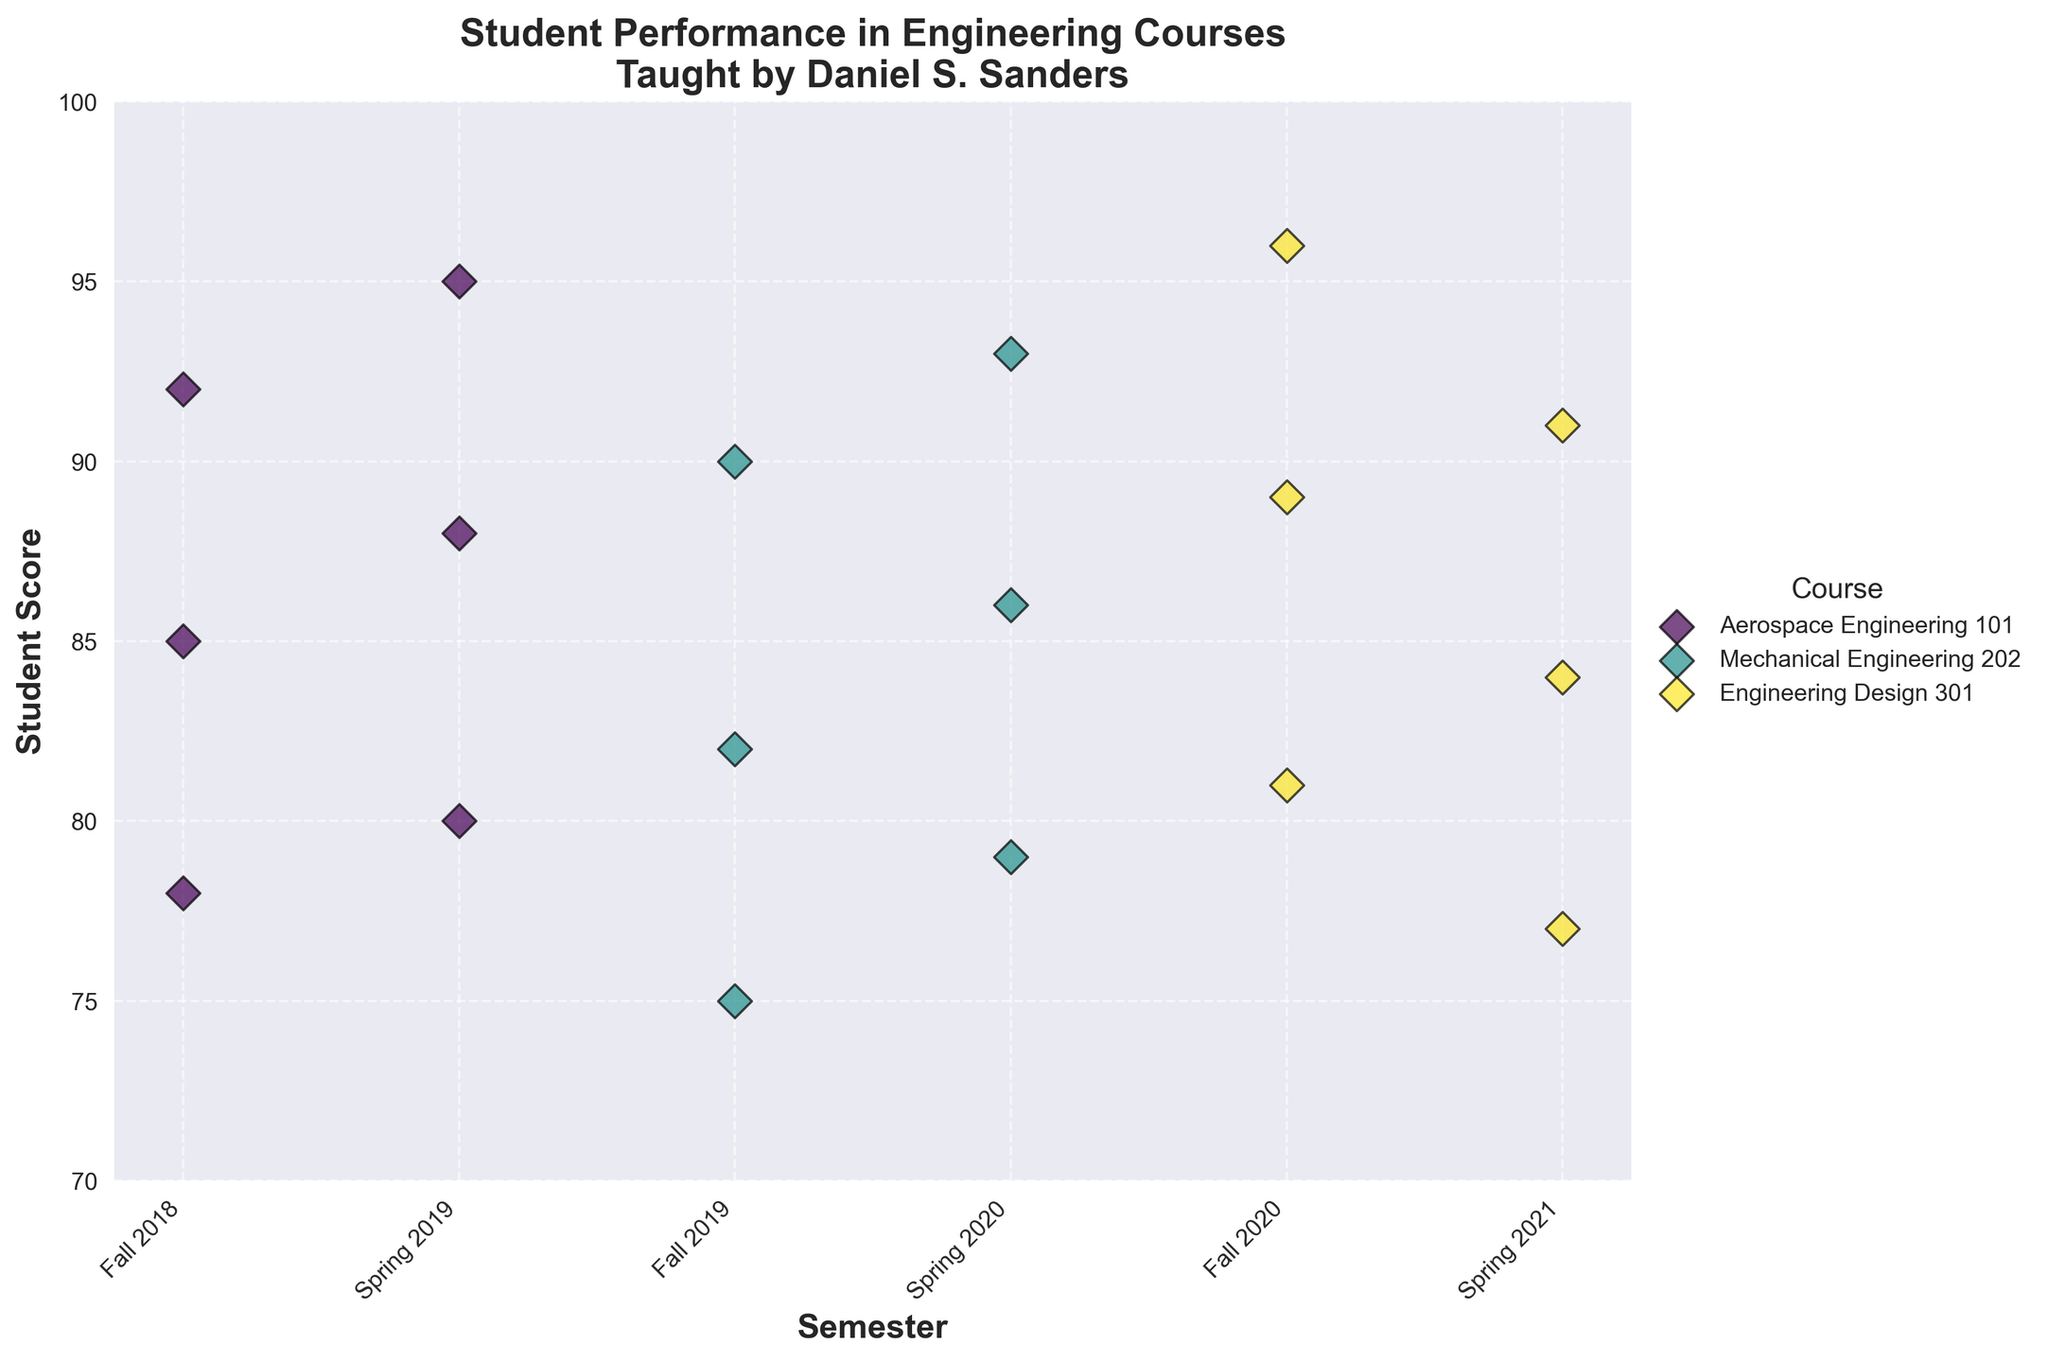What is the title of the figure? The title is usually at the top of the figure. In this case, it reads "Student Performance in Engineering Courses\nTaught by Daniel S. Sanders".
Answer: Student Performance in Engineering Courses Taught by Daniel S. Sanders What are the labels on the x-axis and y-axis? The labels are typically located at the axes. The x-axis label is 'Semester' and the y-axis label is 'Student Score'.
Answer: Semester and Student Score Which semester had the highest number of unique engineering courses? By observing the x-axis categories, note which semester labels have the highest distinct courses plotted. Both Fall 2018 and Spring 2019 show data for just Aerospace Engineering 101, Fall 2019 and Spring 2020 for Mechanical Engineering 202, and Fall 2020 and Spring 2021 for Engineering Design 301.
Answer: Fall 2018, Spring 2019, Fall 2019, Spring 2020, Fall 2020, Spring 2021 each have data for one unique course What is the range of student scores for Mechanical Engineering 202 in Fall 2019? Identify the data points for Mechanical Engineering 202 in Fall 2019. The scores are 75, 82, and 90. The range is the difference between the highest and lowest scores: 90 - 75.
Answer: 15 Is there a course where scores increased in every subsequent semester? Analyze each course individually across the semesters. Aerospace Engineering 101 starts at 78, 85, 92 in Fall 2018 and goes to 80, 88, 95 in Spring 2019 (increasing); Mechanical Engineering 202 has 75, 82, 90 in Fall 2019 to 79, 86, 93 in Spring 2020 (increasing).
Answer: Yes, Aerospace Engineering 101 and Mechanical Engineering 202 Which course and semester have the highest student score? Look for the highest position on the y-axis, which corresponds to the 'Student Score'. The highest score is 96, occurring in multiple instances: Engineering Design 301 in Fall 2020.
Answer: Engineering Design 301, Fall 2020 How does the average score in Engineering Design 301 for Fall 2020 compare with that for Spring 2021? Calculate the average score for each semester. Fall 2020 scores are 81, 89, 96; average is (81 + 89 + 96)/3 = 88.67. Spring 2021 scores are 77, 84, 91; average is (77 + 84 + 91)/3 = 84.
Answer: Fall 2020 has a higher average score Do all courses show at least one student score above 90? For each course, check the scatter points. Aerospace Engineering 101 has scores of 92 and 95, Mechanical Engineering 202 has 90 and 93, and Engineering Design 301 has 96 and 91. Each course shows student scores above 90.
Answer: Yes In which semester did student scores vary the most for Aerospace Engineering 101? Compare the range (max-min) of scores within each semester of Aerospace Engineering 101. Fall 2018: range is 92 - 78 = 14. Spring 2019: range is 95 - 80 = 15.
Answer: Spring 2019 